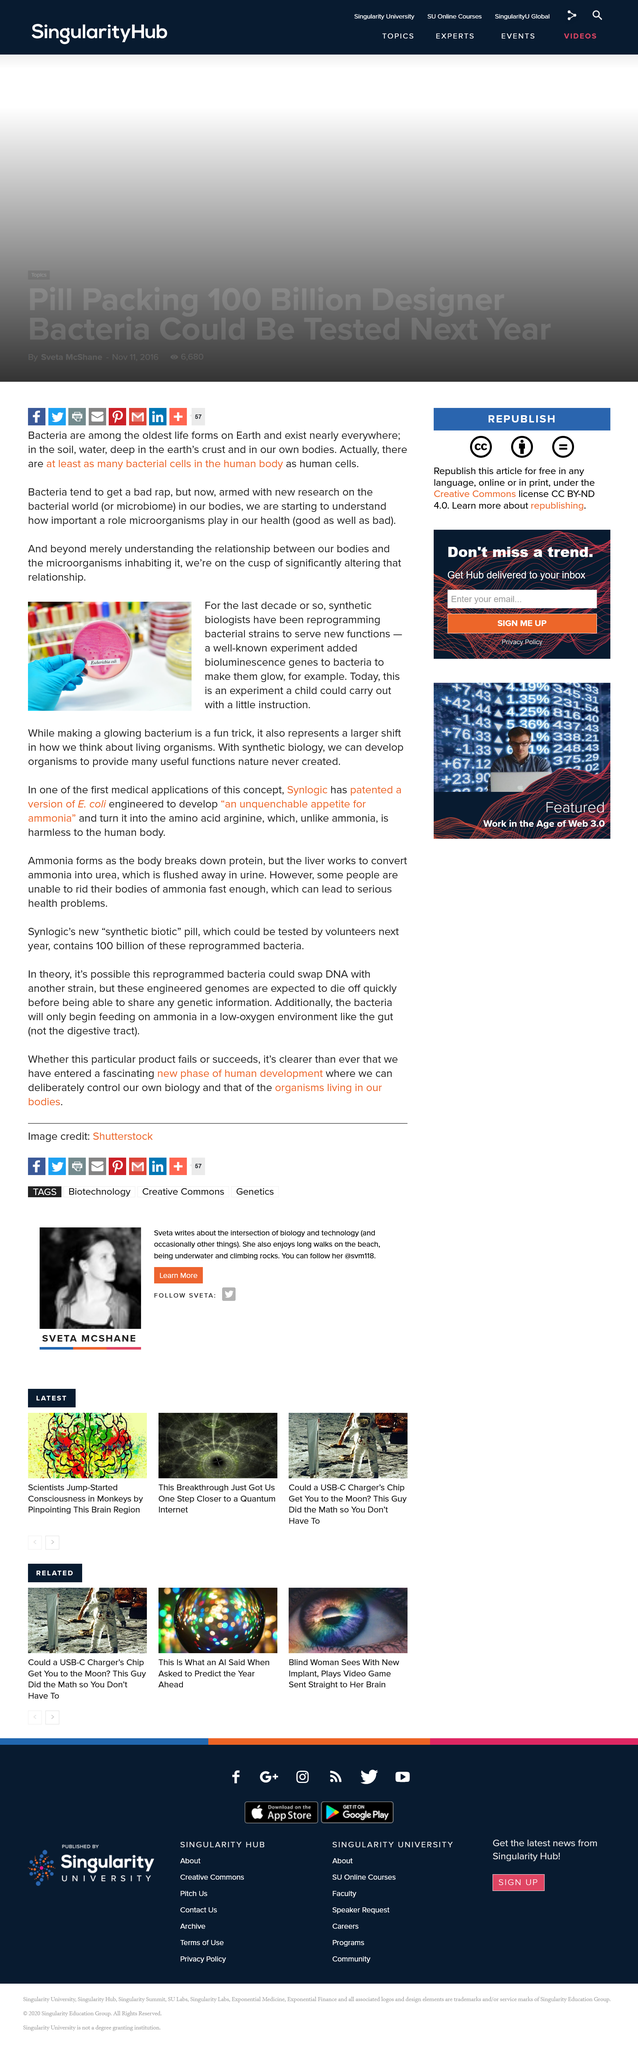Give some essential details in this illustration. The microbiome consists of various places such as the human body, soil, water, and the earth's crust. The term used to refer to the bacterial world is the microbiome. The bacterial world is known as the microbiome. Escherichia coli is an example of a bacterium, which is a type of microorganism. 